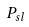<formula> <loc_0><loc_0><loc_500><loc_500>P _ { s l }</formula> 